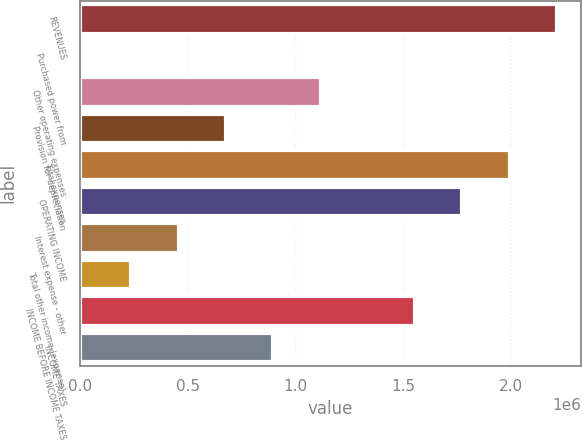Convert chart to OTSL. <chart><loc_0><loc_0><loc_500><loc_500><bar_chart><fcel>REVENUES<fcel>Purchased power from<fcel>Other operating expenses<fcel>Provision for depreciation<fcel>Total expenses<fcel>OPERATING INCOME<fcel>Interest expense - other<fcel>Total other income (expense)<fcel>INCOME BEFORE INCOME TAXES<fcel>INCOME TAXES<nl><fcel>2.21624e+06<fcel>18336<fcel>1.11729e+06<fcel>677706<fcel>1.99645e+06<fcel>1.77666e+06<fcel>457916<fcel>238126<fcel>1.55687e+06<fcel>897496<nl></chart> 